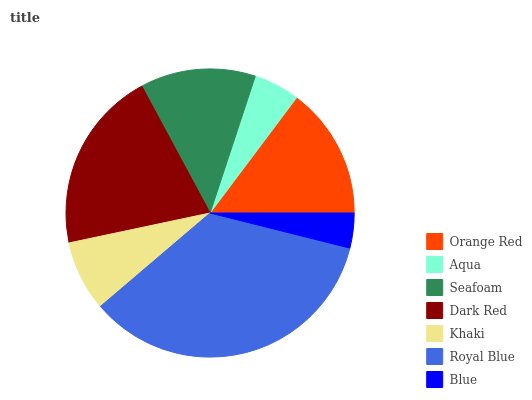Is Blue the minimum?
Answer yes or no. Yes. Is Royal Blue the maximum?
Answer yes or no. Yes. Is Aqua the minimum?
Answer yes or no. No. Is Aqua the maximum?
Answer yes or no. No. Is Orange Red greater than Aqua?
Answer yes or no. Yes. Is Aqua less than Orange Red?
Answer yes or no. Yes. Is Aqua greater than Orange Red?
Answer yes or no. No. Is Orange Red less than Aqua?
Answer yes or no. No. Is Seafoam the high median?
Answer yes or no. Yes. Is Seafoam the low median?
Answer yes or no. Yes. Is Orange Red the high median?
Answer yes or no. No. Is Orange Red the low median?
Answer yes or no. No. 